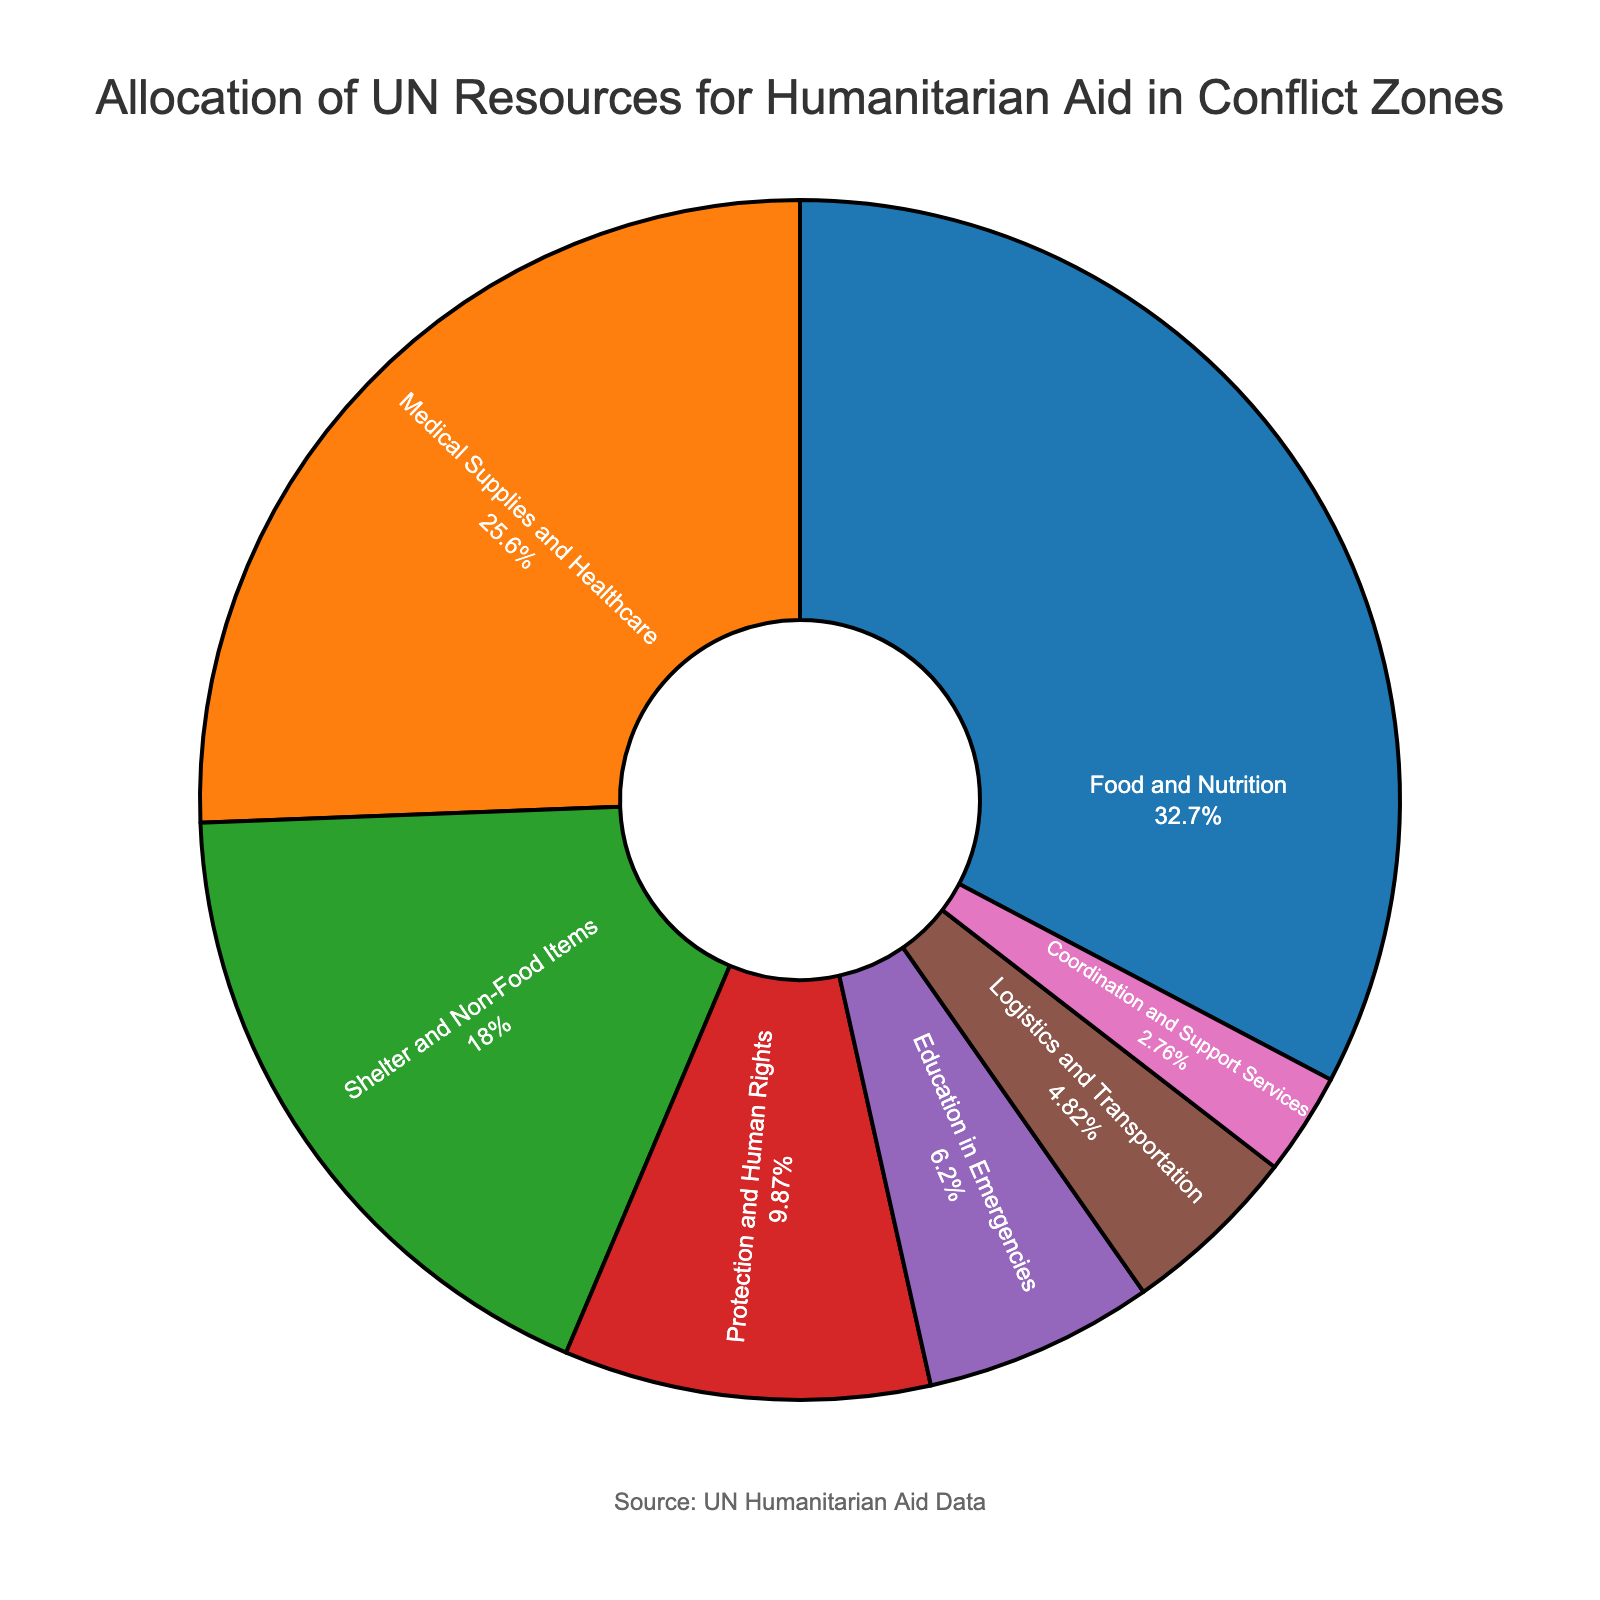What type of humanitarian aid receives the highest allocation of UN resources? The figure shows that "Food and Nutrition" has the largest slice of the pie chart.
Answer: Food and Nutrition What percentage of resources is allocated to Medical Supplies and Healthcare? The figure clearly labels each segment with its percentage, and "Medical Supplies and Healthcare" is shown as 22.3%.
Answer: 22.3% How much more is allocated to Food and Nutrition compared to Education in Emergencies? "Food and Nutrition" is 28.5%, and "Education in Emergencies" is 5.4%. Subtract 5.4 from 28.5 to find the difference. 28.5 - 5.4 = 23.1
Answer: 23.1 If the resources allocated to Shelter and Non-Food Items were doubled, would it surpass the allocation to Food and Nutrition? Shelter and Non-Food Items is 15.7%. Doubling it would make it 15.7 * 2 = 31.4%. This is higher than Food and Nutrition, which is 28.5%.
Answer: Yes Which type of aid is allocated less than 5% of the total resources? The figure shows that "Logistics and Transportation" (4.2%) and "Coordination and Support Services" (2.4%) are the only categories below 5%.
Answer: Logistics and Transportation and Coordination and Support Services How much more (in percentage points) is allocated to Protection and Human Rights compared to Coordination and Support Services? Protection and Human Rights is 8.6%. Coordination and Support Services is 2.4%. Subtract 2.4 from 8.6. 8.6 - 2.4 = 6.2
Answer: 6.2 Which categories combined account for more than half of the resources? Adding together categories until over 50% is reached: 
- Food and Nutrition: 28.5%
- Medical Supplies and Healthcare: 22.3%
28.5 + 22.3 = 50.8%
These two alone sum to over half.
Answer: Food and Nutrition and Medical Supplies and Healthcare What visual cues distinguish the largest allocation category from others in the figure? The largest allocation slice for "Food and Nutrition" is distinctively the widest segment and one of the most prominent colors (blue).
Answer: The widest slice and blue color Rank the aid types from highest to lowest allocation. The percentages on the pie chart are:
1. Food and Nutrition: 28.5%
2. Medical Supplies and Healthcare: 22.3%
3. Shelter and Non-Food Items: 15.7%
4. Protection and Human Rights: 8.6%
5. Education in Emergencies: 5.4%
6. Logistics and Transportation: 4.2%
7. Coordination and Support Services: 2.4%
Answer: Food and Nutrition, Medical Supplies and Healthcare, Shelter and Non-Food Items, Protection and Human Rights, Education in Emergencies, Logistics and Transportation, Coordination and Support Services 